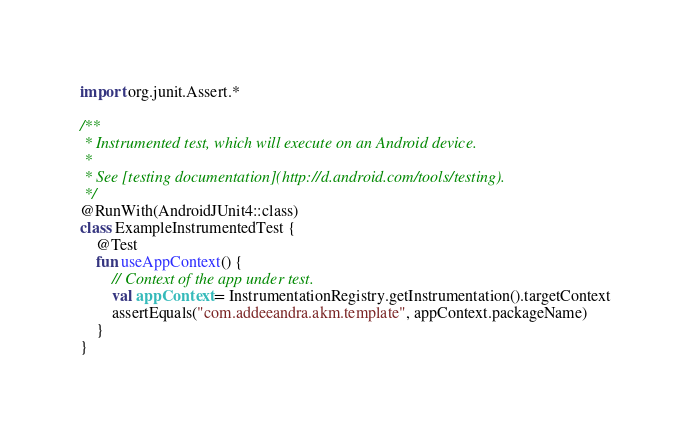Convert code to text. <code><loc_0><loc_0><loc_500><loc_500><_Kotlin_>import org.junit.Assert.*

/**
 * Instrumented test, which will execute on an Android device.
 *
 * See [testing documentation](http://d.android.com/tools/testing).
 */
@RunWith(AndroidJUnit4::class)
class ExampleInstrumentedTest {
    @Test
    fun useAppContext() {
        // Context of the app under test.
        val appContext = InstrumentationRegistry.getInstrumentation().targetContext
        assertEquals("com.addeeandra.akm.template", appContext.packageName)
    }
}</code> 